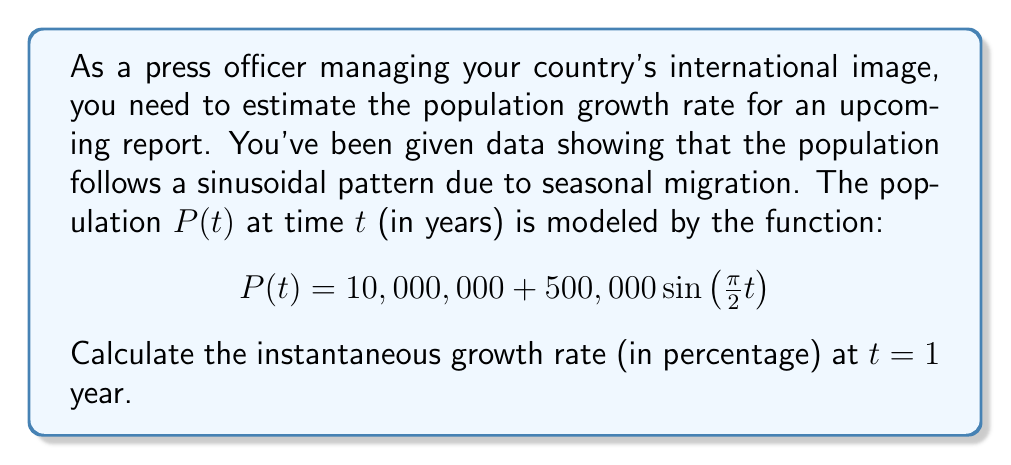Can you solve this math problem? To solve this problem, we need to follow these steps:

1) The instantaneous growth rate is given by the derivative of the population function divided by the population at that time, multiplied by 100 to convert to a percentage:

   $$\text{Growth Rate} = \frac{P'(t)}{P(t)} \times 100\%$$

2) First, let's find $P'(t)$ by differentiating $P(t)$:
   
   $$P'(t) = 500,000 \cdot \frac{\pi}{2} \cos(\frac{\pi}{2}t)$$

3) Now, we need to calculate $P(1)$ and $P'(1)$:

   $P(1) = 10,000,000 + 500,000 \sin(\frac{\pi}{2} \cdot 1)$
   $     = 10,000,000 + 500,000 \cdot 1$
   $     = 10,500,000$

   $P'(1) = 500,000 \cdot \frac{\pi}{2} \cos(\frac{\pi}{2} \cdot 1)$
   $      = 500,000 \cdot \frac{\pi}{2} \cdot 0$
   $      = 0$

4) Now we can calculate the growth rate:

   $$\text{Growth Rate} = \frac{P'(1)}{P(1)} \times 100\% = \frac{0}{10,500,000} \times 100\% = 0\%$$
Answer: The instantaneous growth rate at $t = 1$ year is $0\%$. 